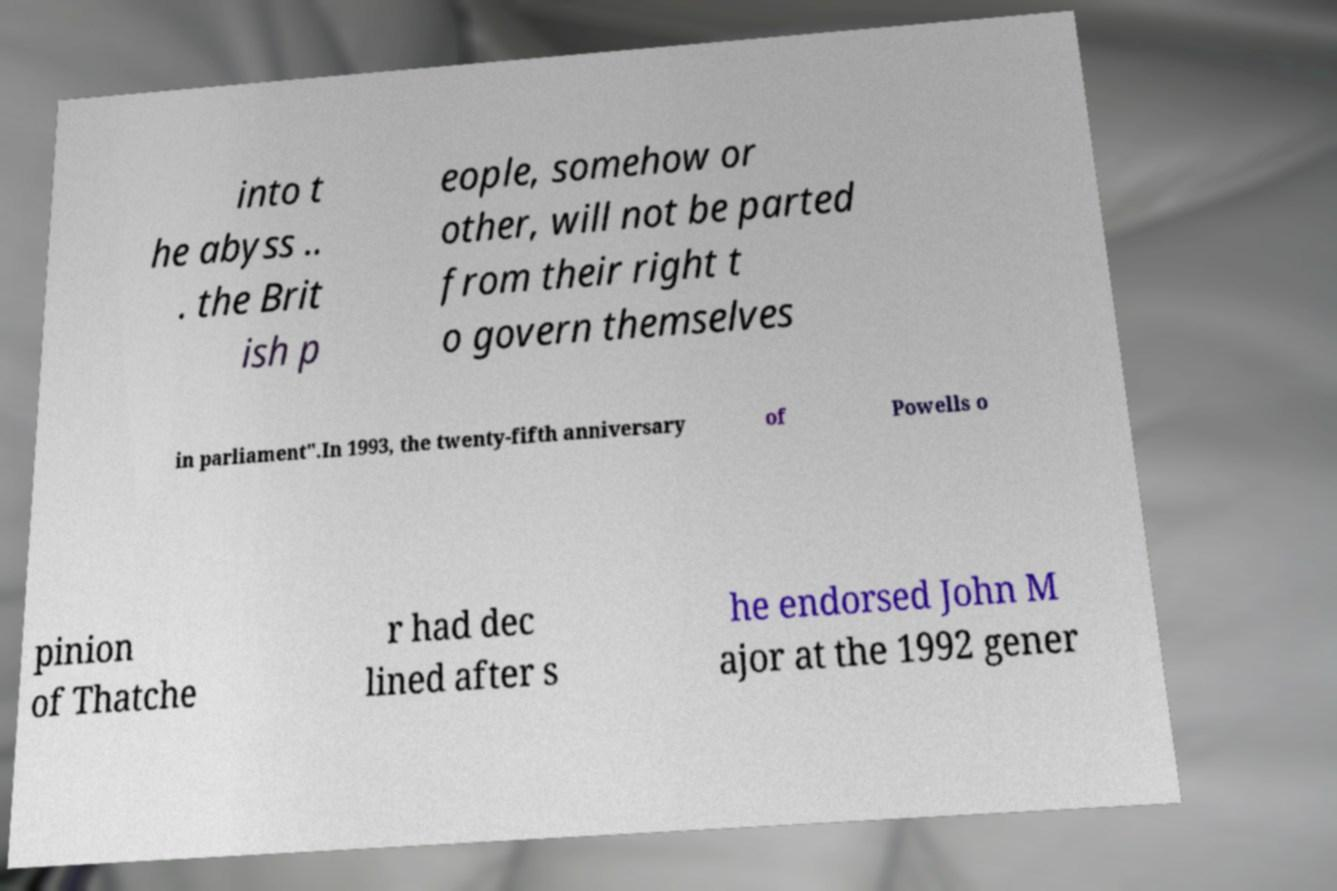Please identify and transcribe the text found in this image. into t he abyss .. . the Brit ish p eople, somehow or other, will not be parted from their right t o govern themselves in parliament".In 1993, the twenty-fifth anniversary of Powells o pinion of Thatche r had dec lined after s he endorsed John M ajor at the 1992 gener 